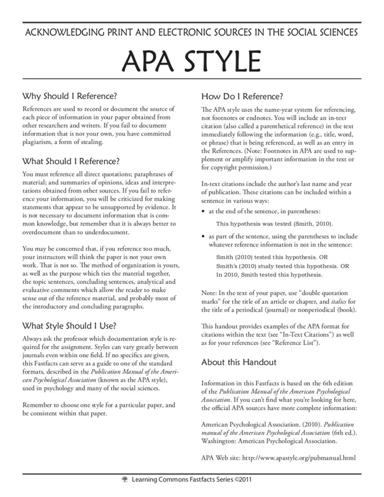When should you use double quotation marks in APA style in the text of your paper? In APA style, double quotation marks are used to enclose direct quotations and to indicate the titles of articles, book chapters, and other shorter works. These marks define exact spoken or written words from another source and to highlight discrete elements within a document. 